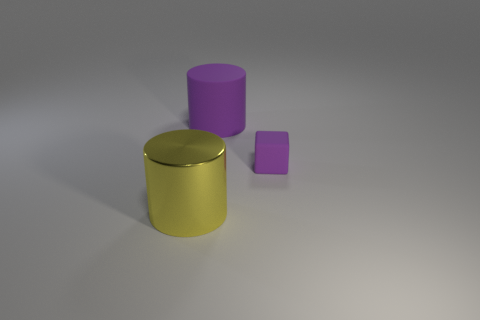Are there any other things that are the same material as the yellow cylinder?
Your answer should be very brief. No. What is the size of the block that is the same color as the rubber cylinder?
Offer a terse response. Small. How many matte objects are there?
Your answer should be compact. 2. How many blue objects are either small matte objects or big objects?
Your answer should be very brief. 0. How many other things are there of the same shape as the large matte object?
Keep it short and to the point. 1. There is a large object right of the metallic cylinder; is its color the same as the rubber thing that is in front of the big rubber thing?
Your answer should be compact. Yes. How many small objects are purple cylinders or metallic objects?
Ensure brevity in your answer.  0. What is the size of the metal thing that is the same shape as the big rubber object?
Offer a very short reply. Large. Are there any other things that have the same size as the matte cube?
Offer a very short reply. No. There is a purple thing left of the purple object that is in front of the big purple rubber object; what is it made of?
Provide a succinct answer. Rubber. 